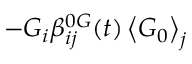Convert formula to latex. <formula><loc_0><loc_0><loc_500><loc_500>- G _ { i } \beta _ { i j } ^ { 0 G } ( t ) \left \langle G _ { 0 } \right \rangle _ { j }</formula> 